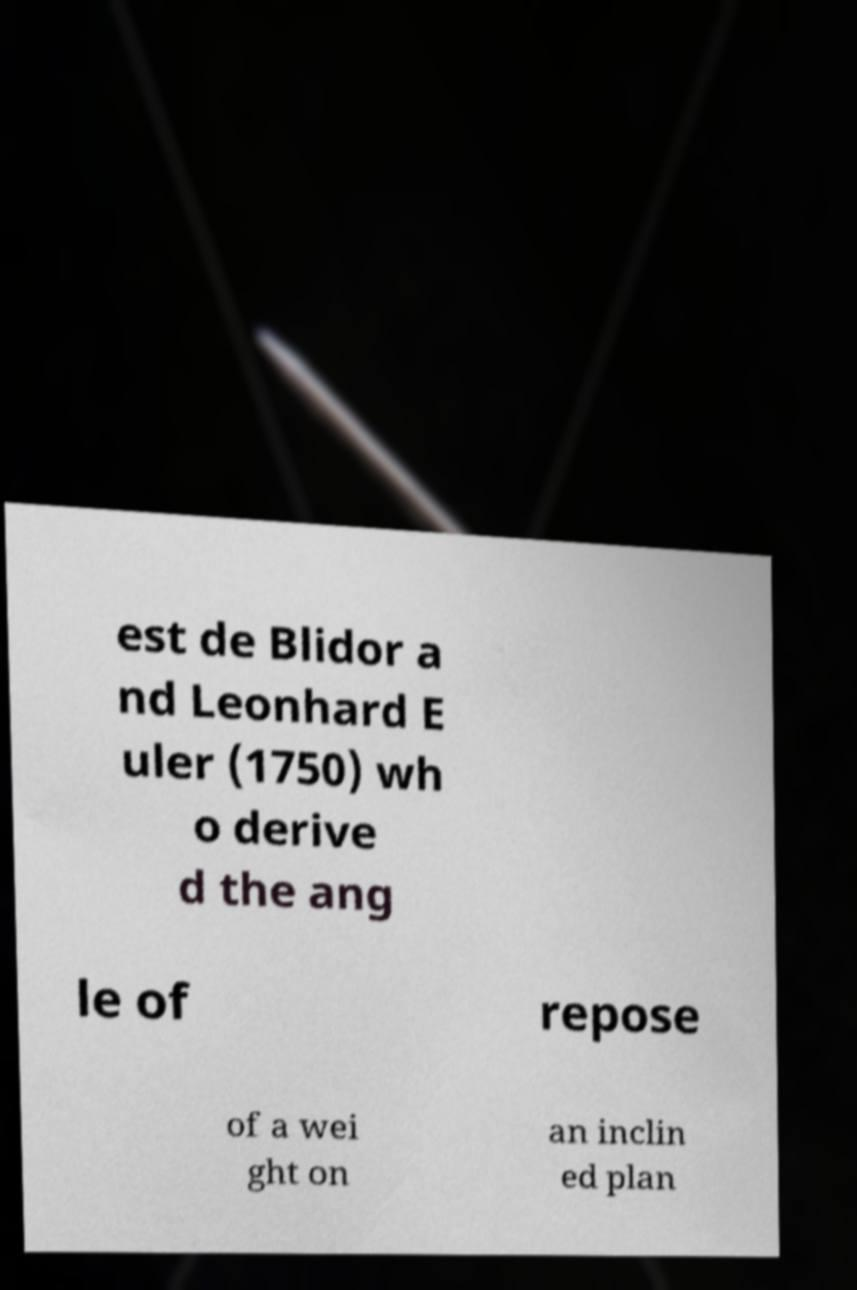Please identify and transcribe the text found in this image. est de Blidor a nd Leonhard E uler (1750) wh o derive d the ang le of repose of a wei ght on an inclin ed plan 